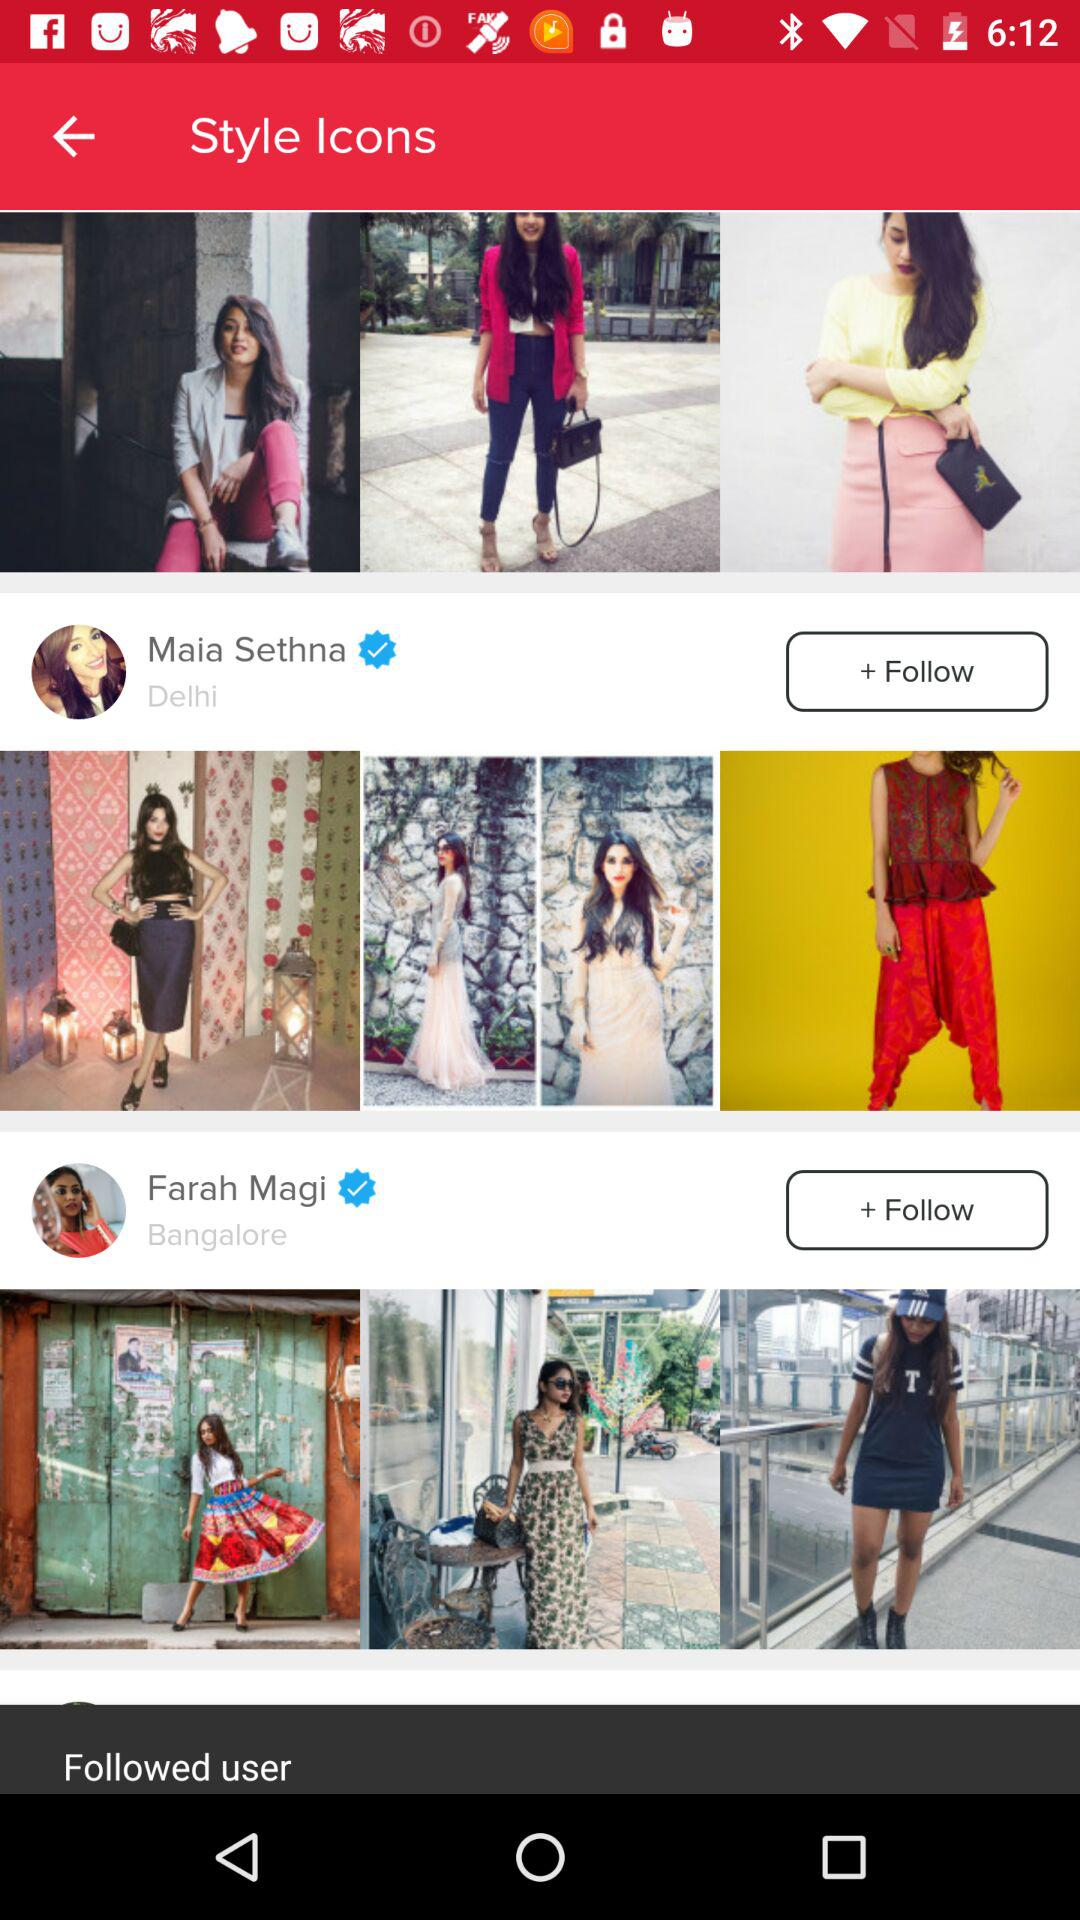Which style icon is shown? The shown style icons are Maia Sethna and Farah Magi. 